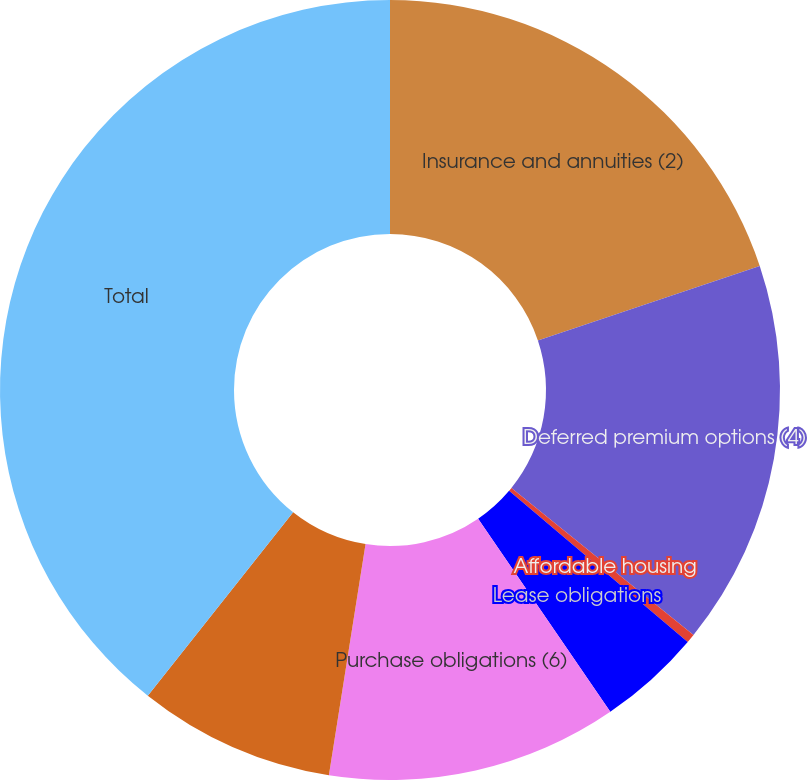<chart> <loc_0><loc_0><loc_500><loc_500><pie_chart><fcel>Insurance and annuities (2)<fcel>Deferred premium options (4)<fcel>Affordable housing<fcel>Lease obligations<fcel>Purchase obligations (6)<fcel>Interest on long-term debt (7)<fcel>Total<nl><fcel>19.85%<fcel>15.96%<fcel>0.37%<fcel>4.27%<fcel>12.06%<fcel>8.16%<fcel>39.34%<nl></chart> 